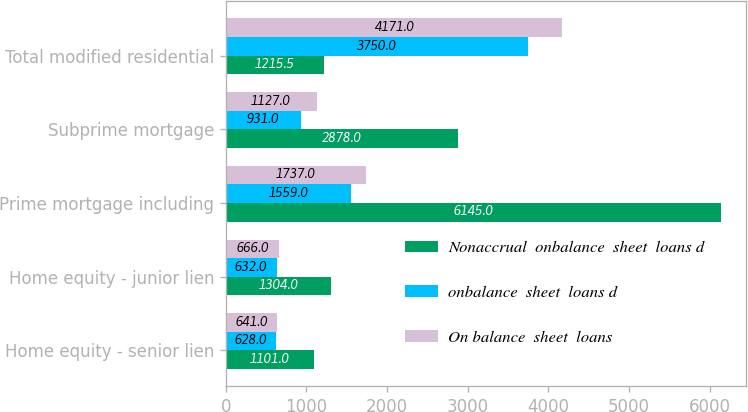Convert chart. <chart><loc_0><loc_0><loc_500><loc_500><stacked_bar_chart><ecel><fcel>Home equity - senior lien<fcel>Home equity - junior lien<fcel>Prime mortgage including<fcel>Subprime mortgage<fcel>Total modified residential<nl><fcel>Nonaccrual  onbalance  sheet  loans d<fcel>1101<fcel>1304<fcel>6145<fcel>2878<fcel>1215.5<nl><fcel>onbalance  sheet  loans d<fcel>628<fcel>632<fcel>1559<fcel>931<fcel>3750<nl><fcel>On balance  sheet  loans<fcel>641<fcel>666<fcel>1737<fcel>1127<fcel>4171<nl></chart> 